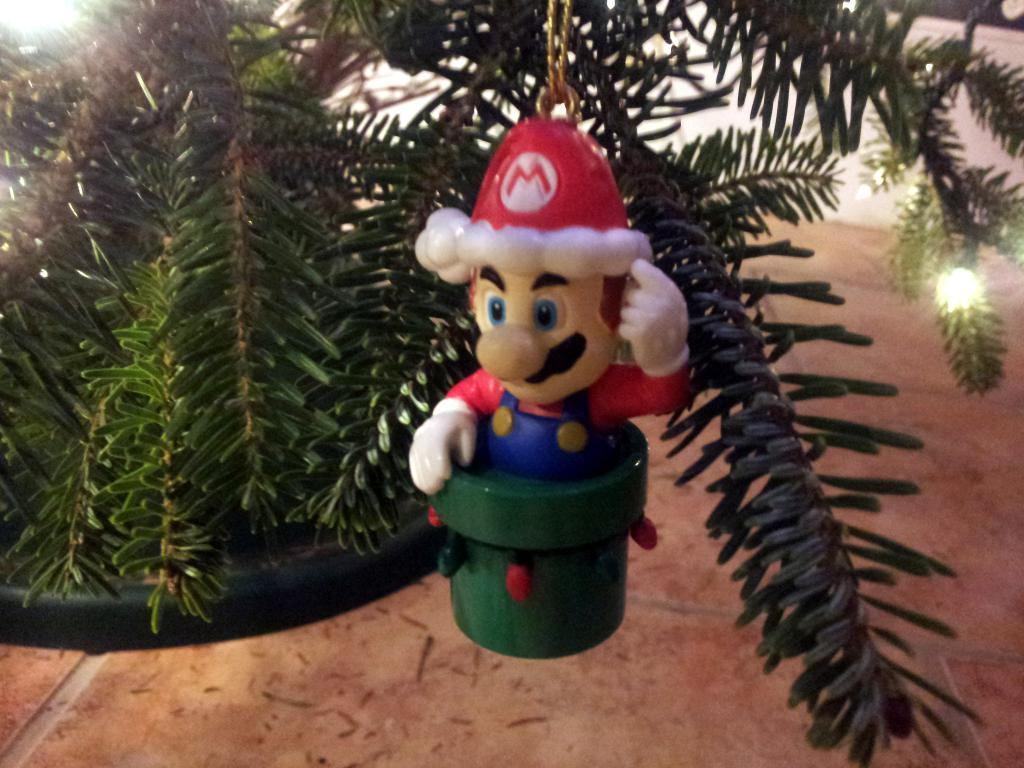What object can be seen in the image? There is a toy in the image. Where is the toy located? The toy is hanged on a tree. What surface is visible in the image? There is a floor visible in the image. Can you see the grandmother playing chess with the toy in the image? There is no grandmother or chess game present in the image; it only features a toy hanging on a tree. 